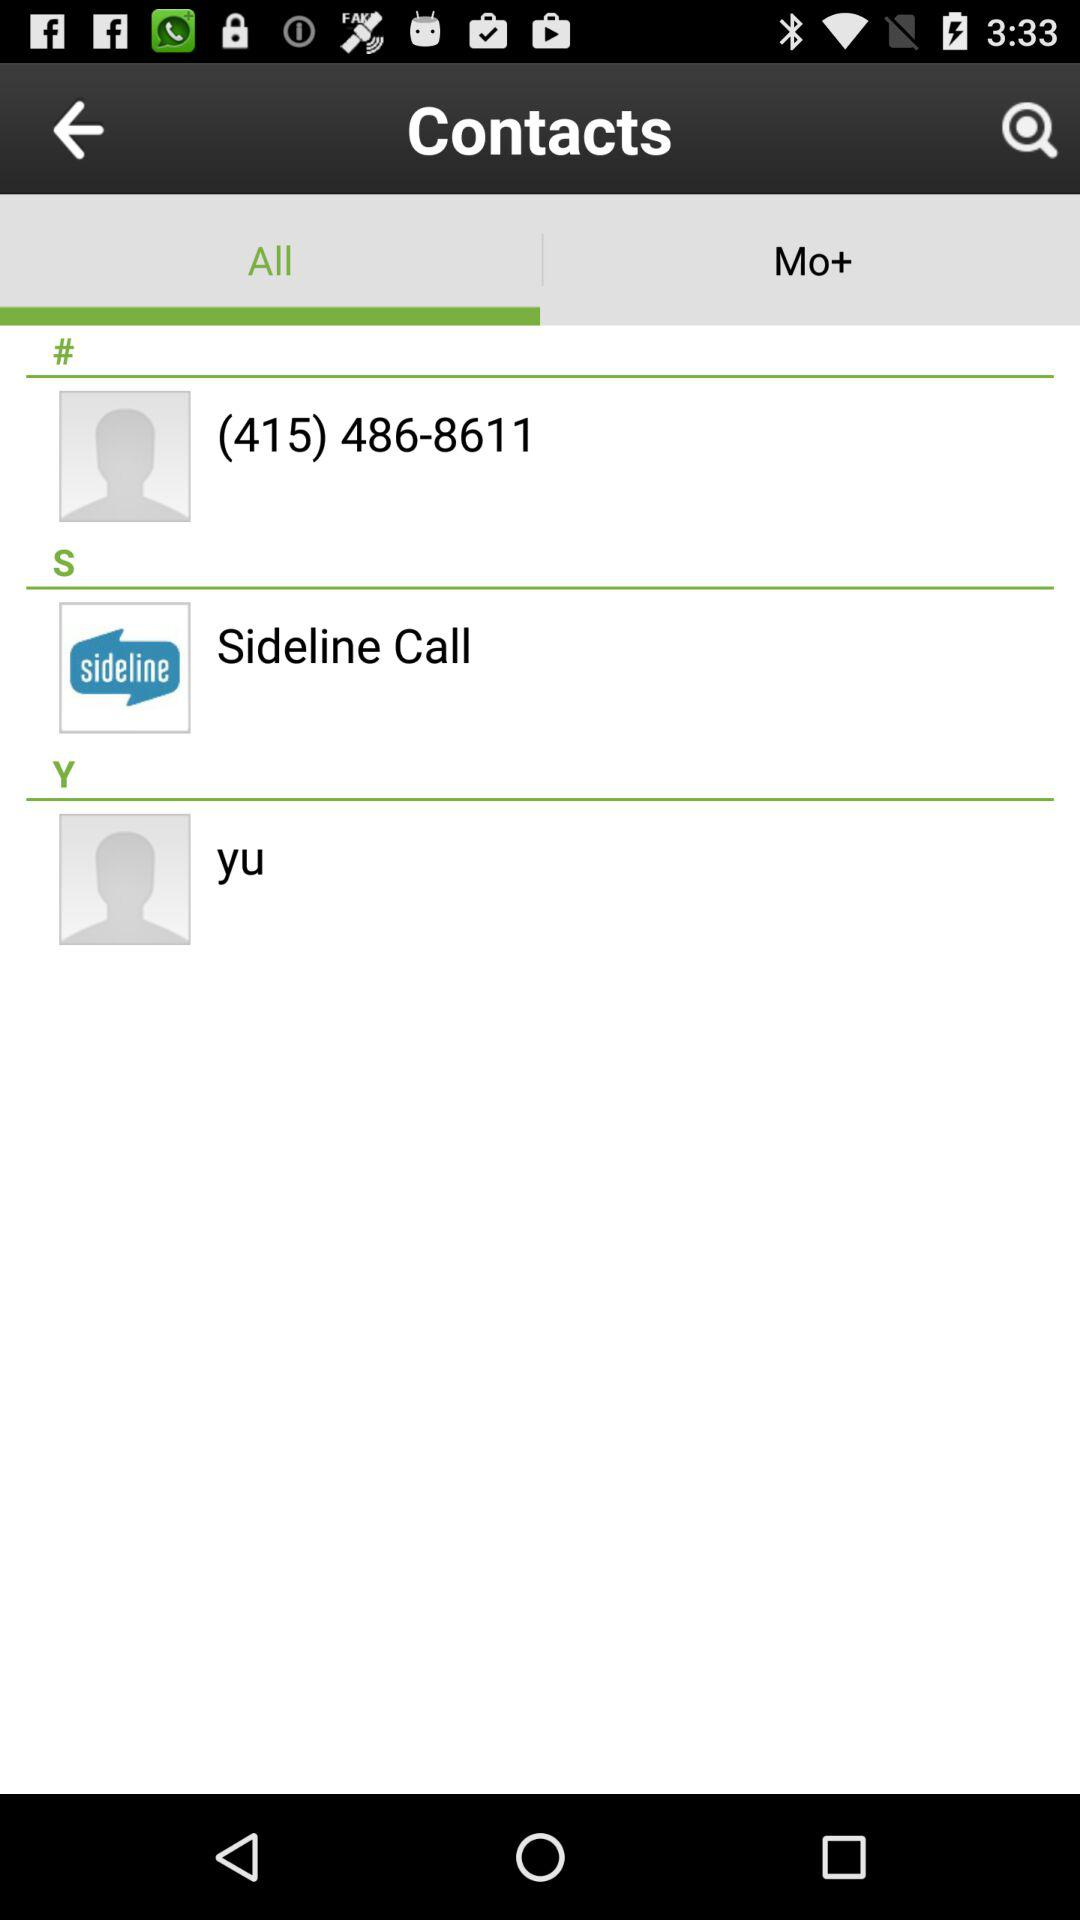What is the contact number ending with 8611? The contact number ending with 8611 is (415) 486-8611. 